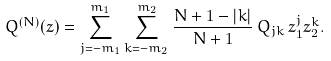Convert formula to latex. <formula><loc_0><loc_0><loc_500><loc_500>Q ^ { ( N ) } ( z ) = \sum _ { j = - m _ { 1 } } ^ { m _ { 1 } } \sum _ { k = - m _ { 2 } } ^ { m _ { 2 } } \frac { N + 1 - | k | } { N + 1 } \, Q _ { j k } \, z _ { 1 } ^ { j } z _ { 2 } ^ { k } .</formula> 